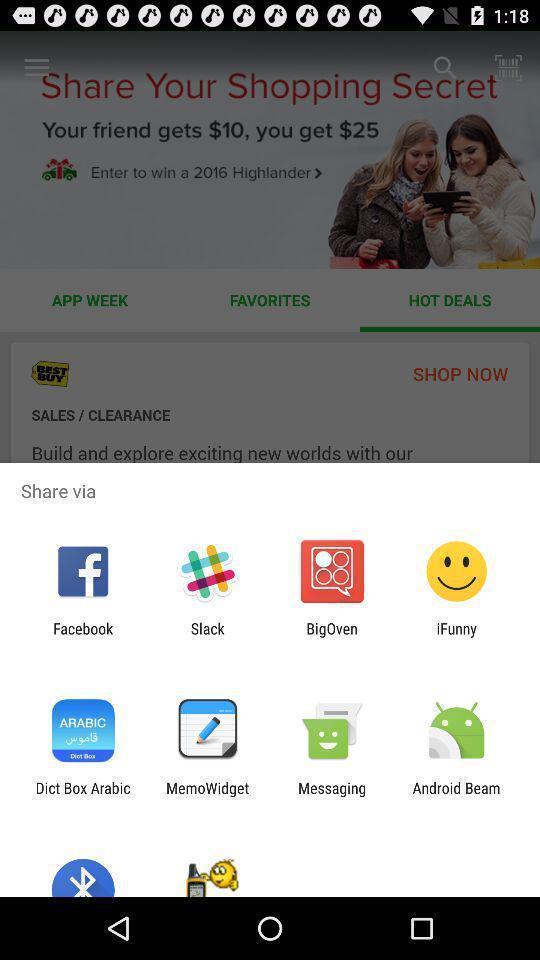What can you discern from this picture? Share options page of a shopping app. 